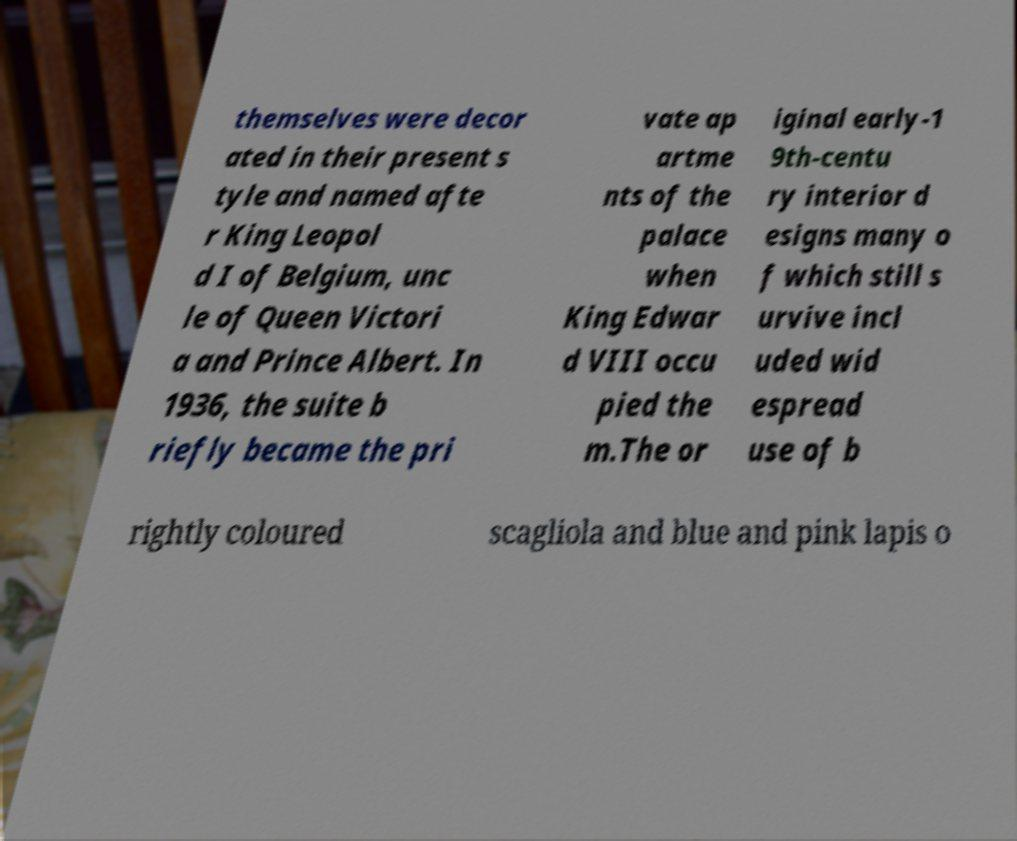Can you read and provide the text displayed in the image?This photo seems to have some interesting text. Can you extract and type it out for me? themselves were decor ated in their present s tyle and named afte r King Leopol d I of Belgium, unc le of Queen Victori a and Prince Albert. In 1936, the suite b riefly became the pri vate ap artme nts of the palace when King Edwar d VIII occu pied the m.The or iginal early-1 9th-centu ry interior d esigns many o f which still s urvive incl uded wid espread use of b rightly coloured scagliola and blue and pink lapis o 